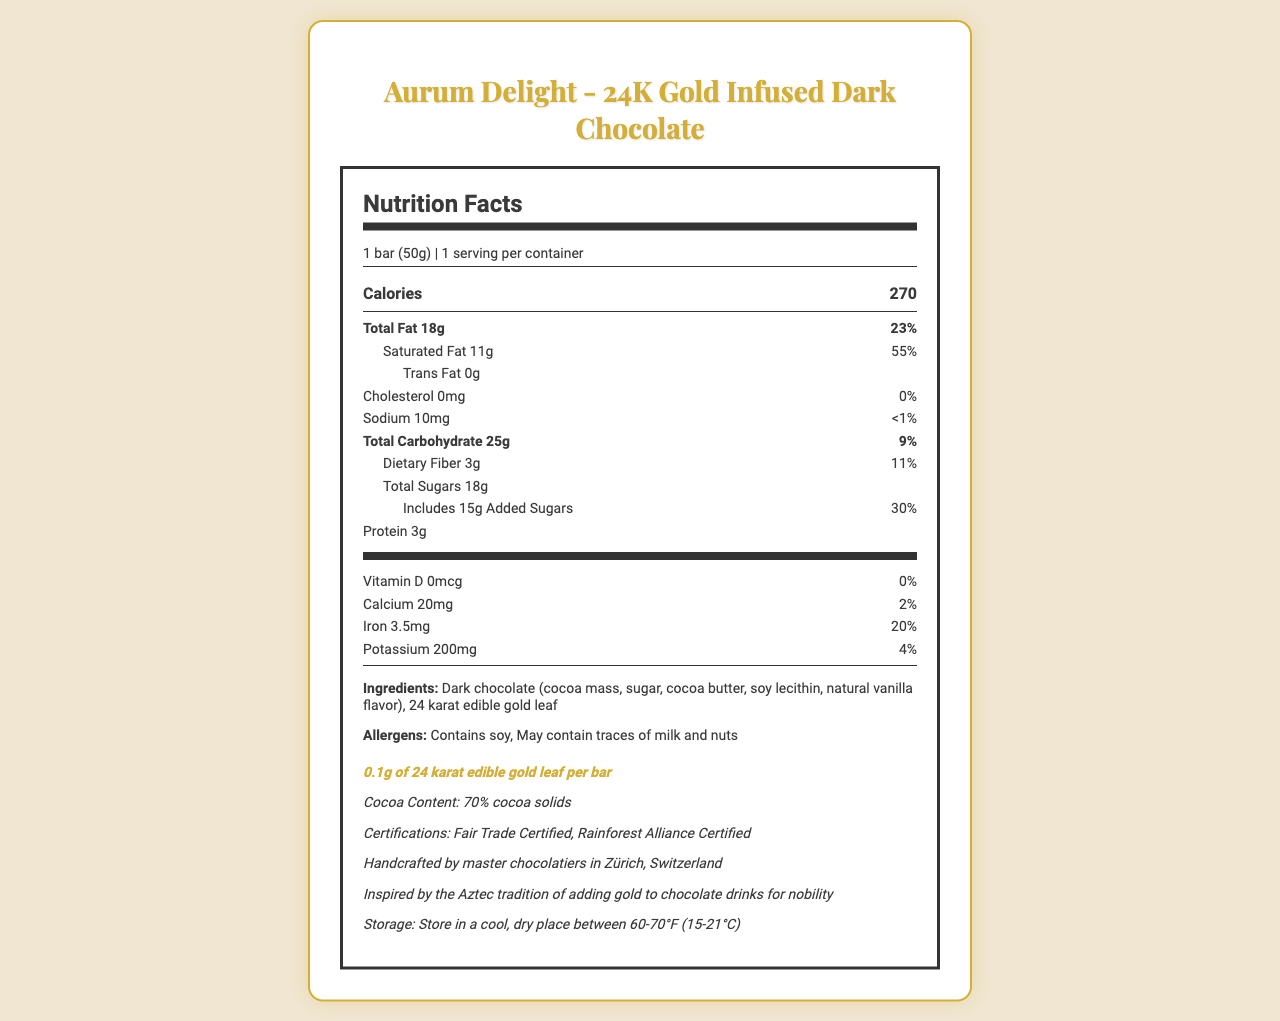What is the main ingredient in the Aurum Delight - 24K Gold Infused Dark Chocolate bar? The main ingredient listed in the document is "Dark chocolate (cocoa mass, sugar, cocoa butter, soy lecithin, natural vanilla flavor)".
Answer: Dark chocolate How many grams of sugar are there in one bar? The document states "Total Sugars: 18g".
Answer: 18g What is the percentage of the daily value of saturated fat per serving? The document notes that the saturated fat content is 11g per serving, which is 55% of the daily value.
Answer: 55% Does the chocolate bar contain any trans fat? The document specifies "Trans Fat: 0g", indicating no trans fat content.
Answer: No How much iron is in one serving of the chocolate bar? The nutrition label indicates that one serving contains 3.5mg of iron.
Answer: 3.5mg Which certifications does the Aurum Delight - 24K Gold Infused Dark Chocolate bar have? A. Organic Certified B. Fair Trade Certified C. Gluten-Free D. Rainforest Alliance Certified The document lists "Fair Trade Certified" and "Rainforest Alliance Certified" under certifications.
Answer: B and D What is the total fat content in the chocolate bar? A. 10g B. 15g C. 18g D. 20g The document clearly states "Total Fat: 18g".
Answer: C Is there any cholesterol in the Aurum Delight chocolate bar? The nutrition label shows "Cholesterol: 0mg", indicating that there is no cholesterol in the bar.
Answer: No Summarize the main nutritional and additional information provided for the Aurum Delight - 24K Gold Infused Dark Chocolate bar. The document provides detailed nutritional information, including fat, carbohydrate, and protein contents. Additionally, it highlights unique elements such as the gold content, cocoa content, certifications, historical insights, and storage instructions, portraying the luxury and quality of the product.
Answer: The Aurum Delight - 24K Gold Infused Dark Chocolate bar is a luxury product containing dark chocolate with 24 karat edible gold leaf. Each 50g bar provides 270 calories, with significant fats and sugars. It is handcrafted, includes Fair Trade and Rainforest Alliance certifications, and has a rich historical background tied to Aztec traditions. What is the cocoa content of the chocolate bar? The document includes an additional information section that mentions "Cocoa Content: 70% cocoa solids".
Answer: 70% cocoa solids Are there any allergen warnings associated with this product? The allergens listed in the document are "Contains soy, May contain traces of milk and nuts".
Answer: Yes What is the daily value percentage of calcium in one serving? The document states that one serving provides 20mg of calcium, which is 2% of the daily value.
Answer: 2% How much 24K edible gold leaf does each bar contain? The document specifies that each bar contains "0.1g of 24 karat edible gold leaf".
Answer: 0.1g Who handcrafted the chocolate bar, and where? The additional information section notes that the chocolate is "Handcrafted by master chocolatiers in Zürich, Switzerland".
Answer: Master chocolatiers in Zürich, Switzerland What is the historical inspiration behind adding gold to the Aurum Delight chocolate bar? The document includes a historical insight mentioning "Inspired by the Aztec tradition of adding gold to chocolate drinks for nobility".
Answer: Aztec tradition of adding gold to chocolate drinks for nobility Is the Aurum Delight bar gluten-free? The document does not provide any information regarding whether the chocolate bar is gluten-free or not.
Answer: Not enough information 